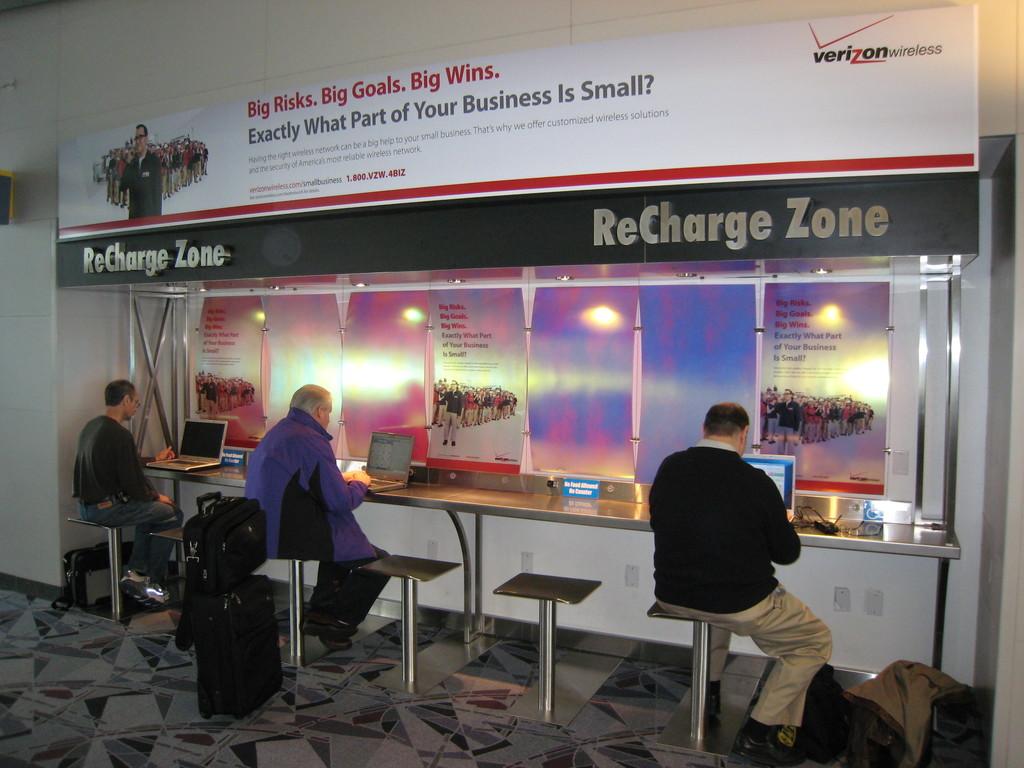What company is in the top right corner?
Offer a very short reply. Verizon. What zone are they in?
Give a very brief answer. Recharge. 